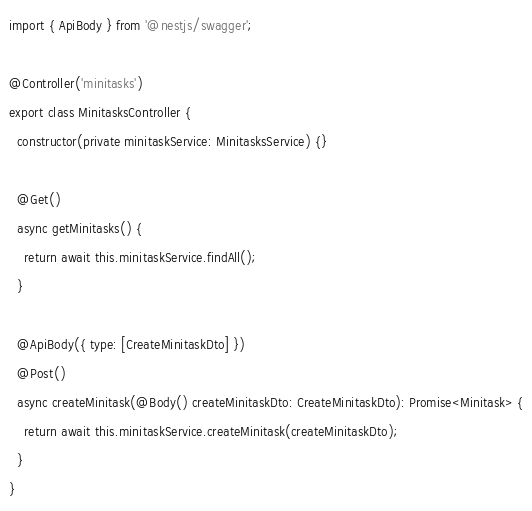Convert code to text. <code><loc_0><loc_0><loc_500><loc_500><_TypeScript_>import { ApiBody } from '@nestjs/swagger';

@Controller('minitasks')
export class MinitasksController {
  constructor(private minitaskService: MinitasksService) {}

  @Get()
  async getMinitasks() {
    return await this.minitaskService.findAll();
  }

  @ApiBody({ type: [CreateMinitaskDto] })
  @Post()
  async createMinitask(@Body() createMinitaskDto: CreateMinitaskDto): Promise<Minitask> {
    return await this.minitaskService.createMinitask(createMinitaskDto);
  }
}
</code> 